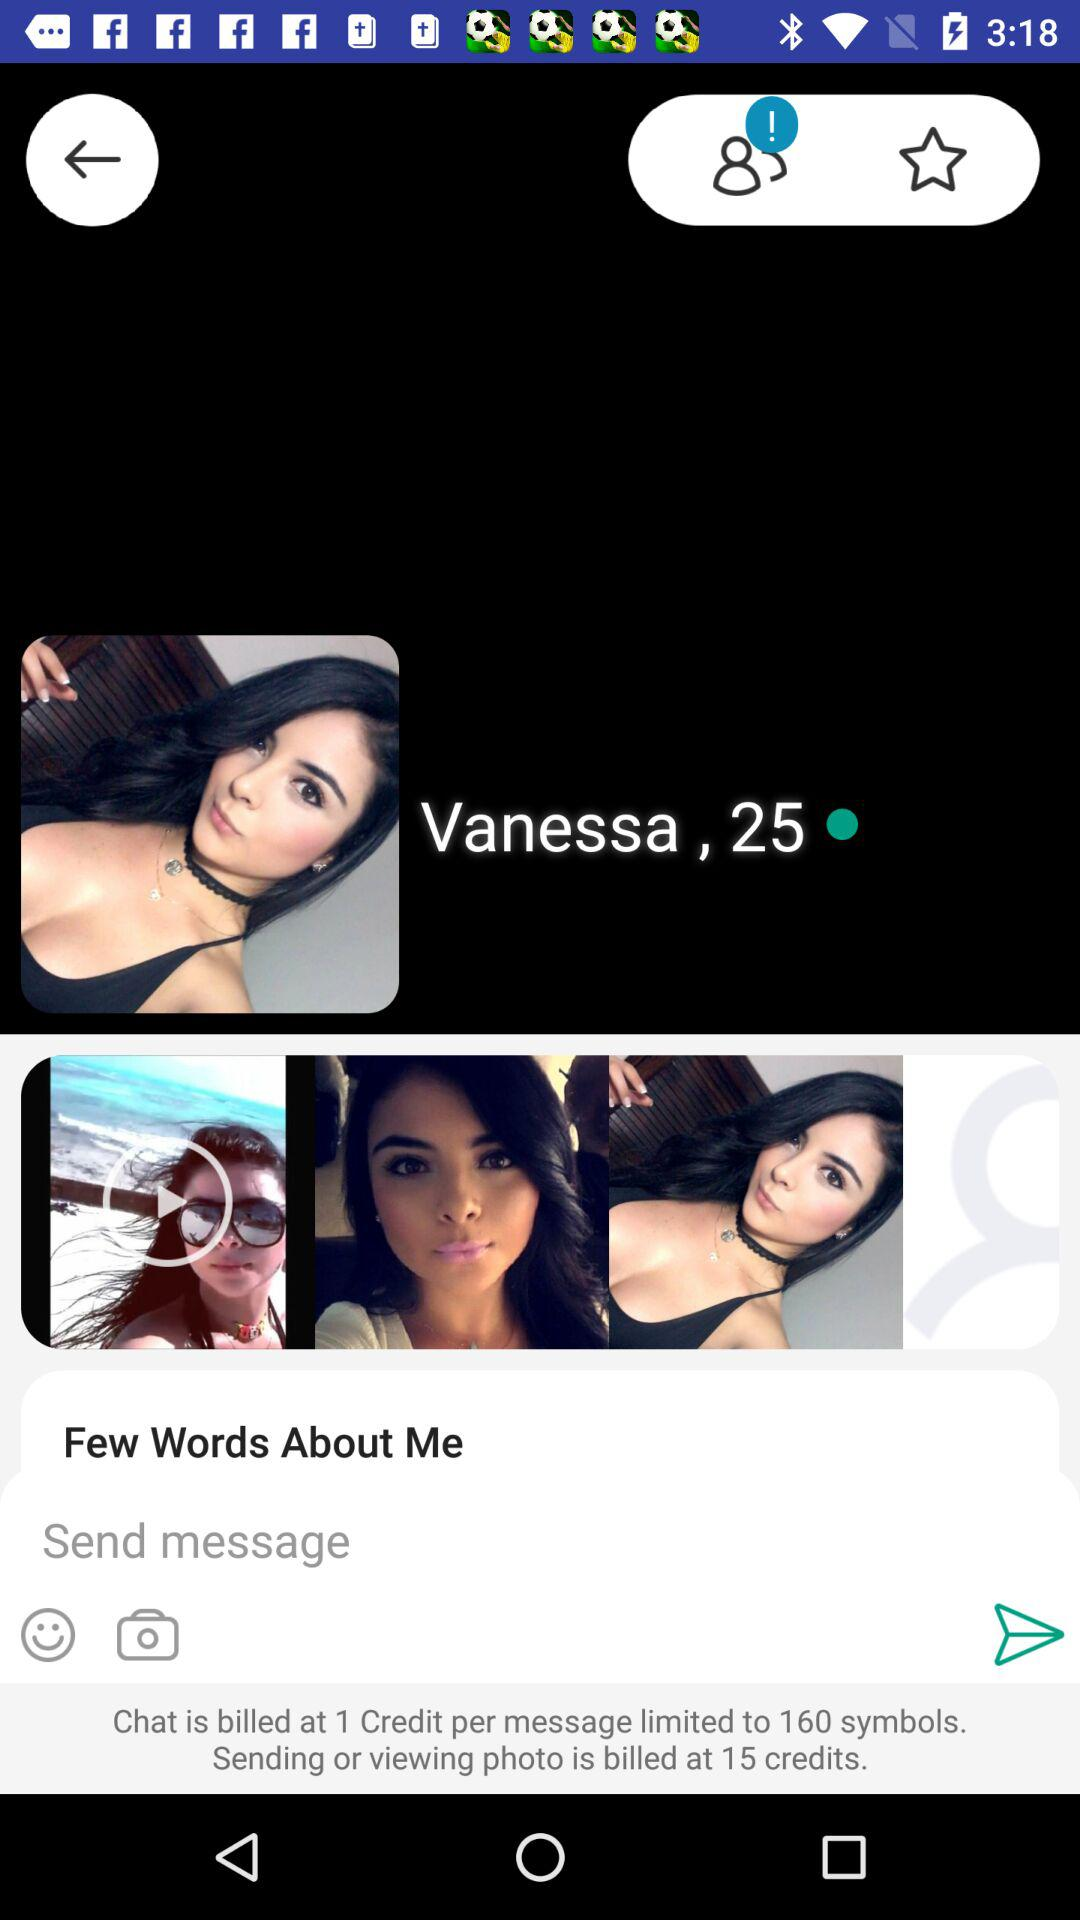What is the limit of symbols for chat billed at one Credit per message? The limit of symbols for chat billed at one Credit per message is 160. 